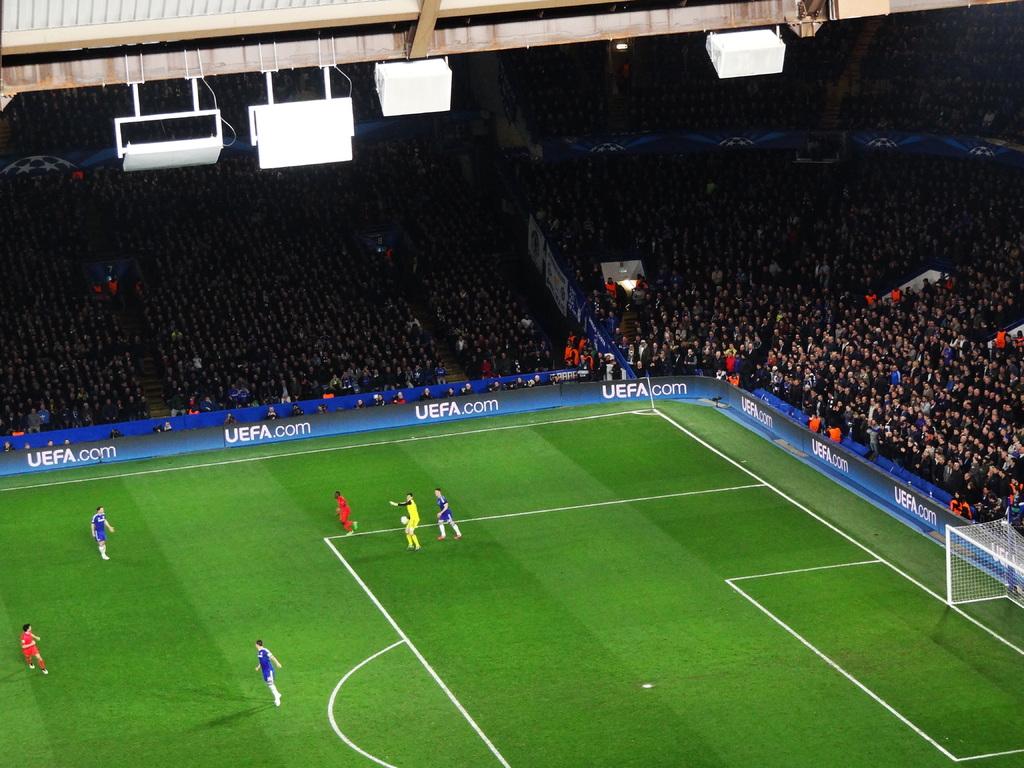What website is displayed repeatedly around the field?
Your answer should be very brief. Uefa.com. 